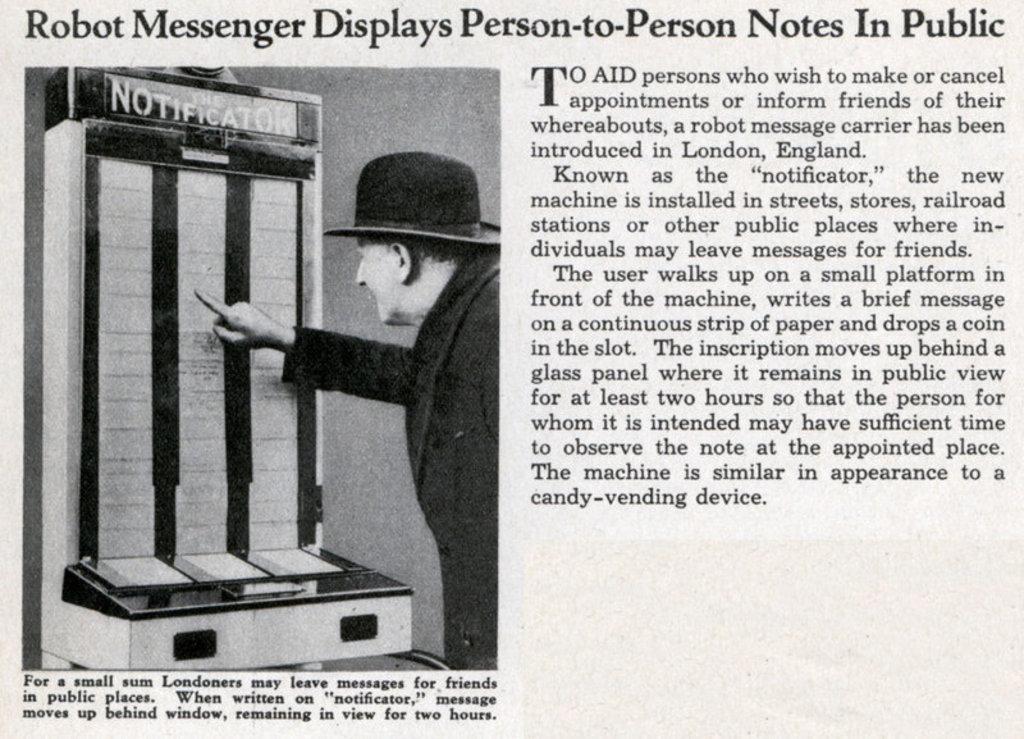Can you describe this image briefly? In this picture, we can see a paper and on the paper there is an image of a person with a hat. In front of the person there is an object. On the paper it is written something. 